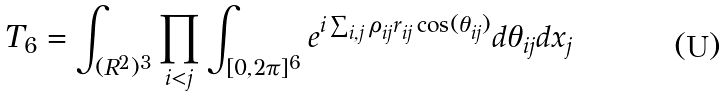<formula> <loc_0><loc_0><loc_500><loc_500>T _ { 6 } = \int _ { ( R ^ { 2 } ) ^ { 3 } } \prod _ { i < j } \int _ { [ 0 , 2 \pi ] ^ { 6 } } e ^ { i \sum _ { i , j } \rho _ { i j } r _ { i j } \cos ( \theta _ { i j } ) } d \theta _ { i j } d x _ { j }</formula> 